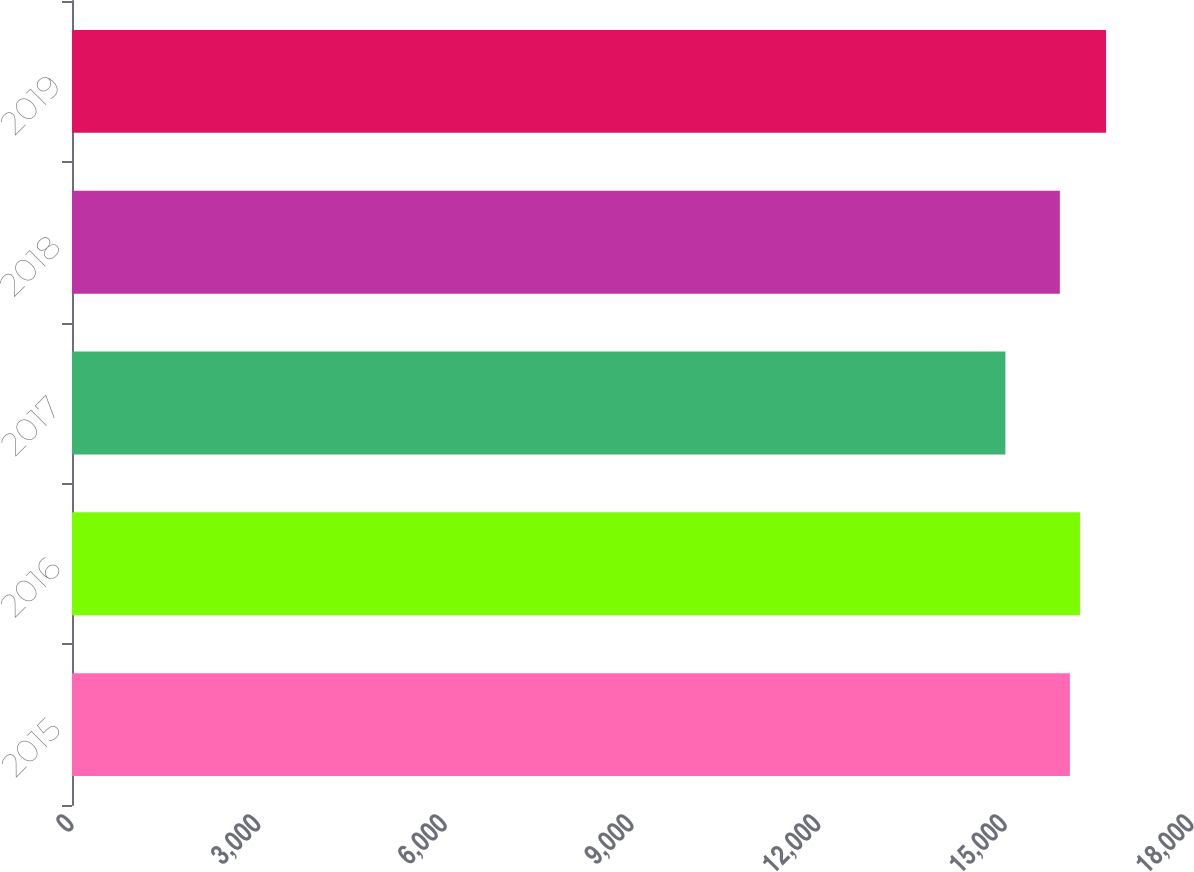Convert chart. <chart><loc_0><loc_0><loc_500><loc_500><bar_chart><fcel>2015<fcel>2016<fcel>2017<fcel>2018<fcel>2019<nl><fcel>16037.8<fcel>16199.6<fcel>15001<fcel>15876<fcel>16619<nl></chart> 